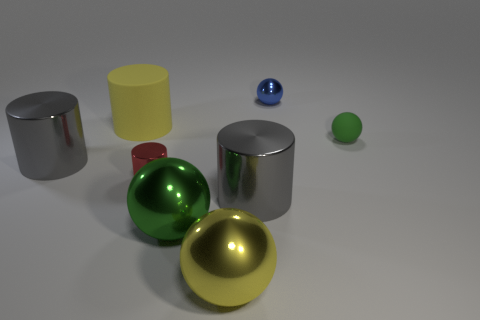Subtract all purple cubes. How many gray cylinders are left? 2 Subtract all tiny red metallic cylinders. How many cylinders are left? 3 Add 2 big matte objects. How many objects exist? 10 Subtract 1 cylinders. How many cylinders are left? 3 Subtract all yellow balls. How many balls are left? 3 Subtract all red spheres. Subtract all yellow blocks. How many spheres are left? 4 Add 1 large yellow matte objects. How many large yellow matte objects exist? 2 Subtract 0 purple blocks. How many objects are left? 8 Subtract all large metal spheres. Subtract all red metallic things. How many objects are left? 5 Add 1 tiny green rubber objects. How many tiny green rubber objects are left? 2 